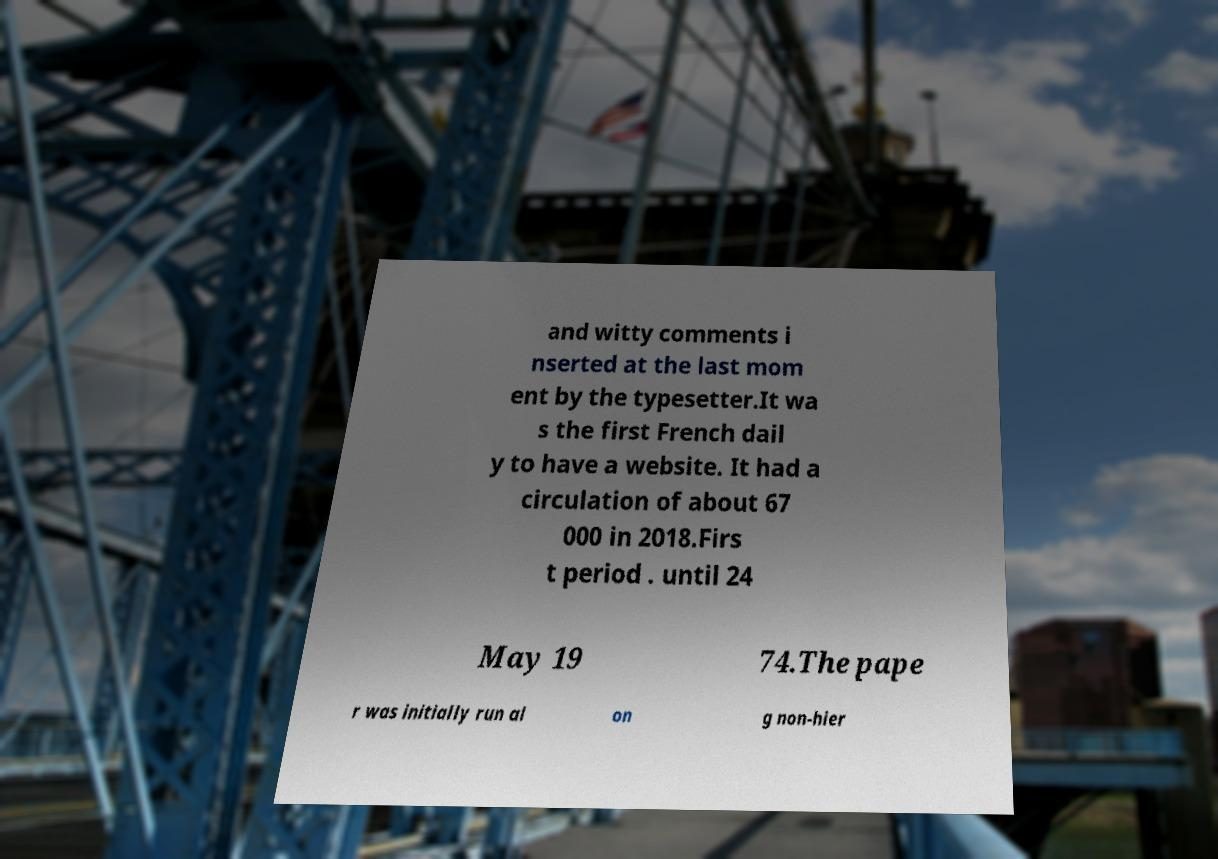There's text embedded in this image that I need extracted. Can you transcribe it verbatim? and witty comments i nserted at the last mom ent by the typesetter.It wa s the first French dail y to have a website. It had a circulation of about 67 000 in 2018.Firs t period . until 24 May 19 74.The pape r was initially run al on g non-hier 